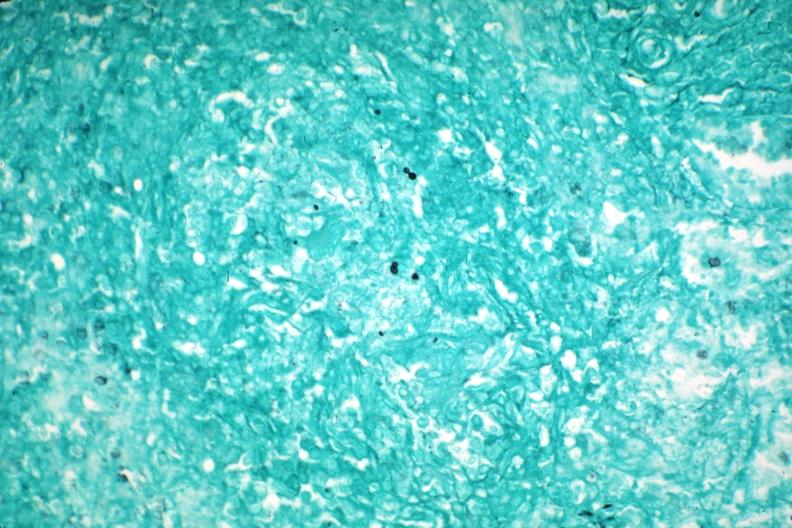what does this image show?
Answer the question using a single word or phrase. Gms granuloma due to pneumocystis aids case 